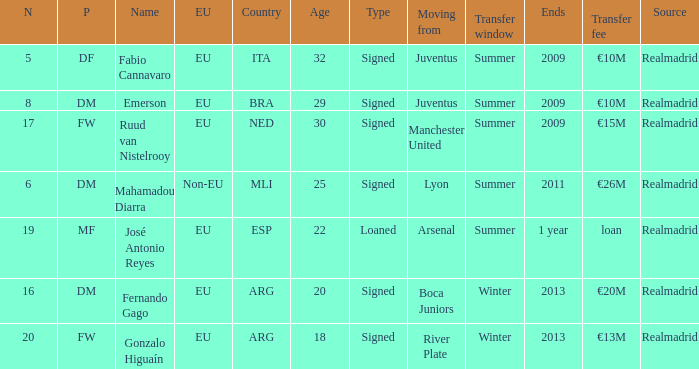What is the player's position who had a €20m transfer fee? Signed. 